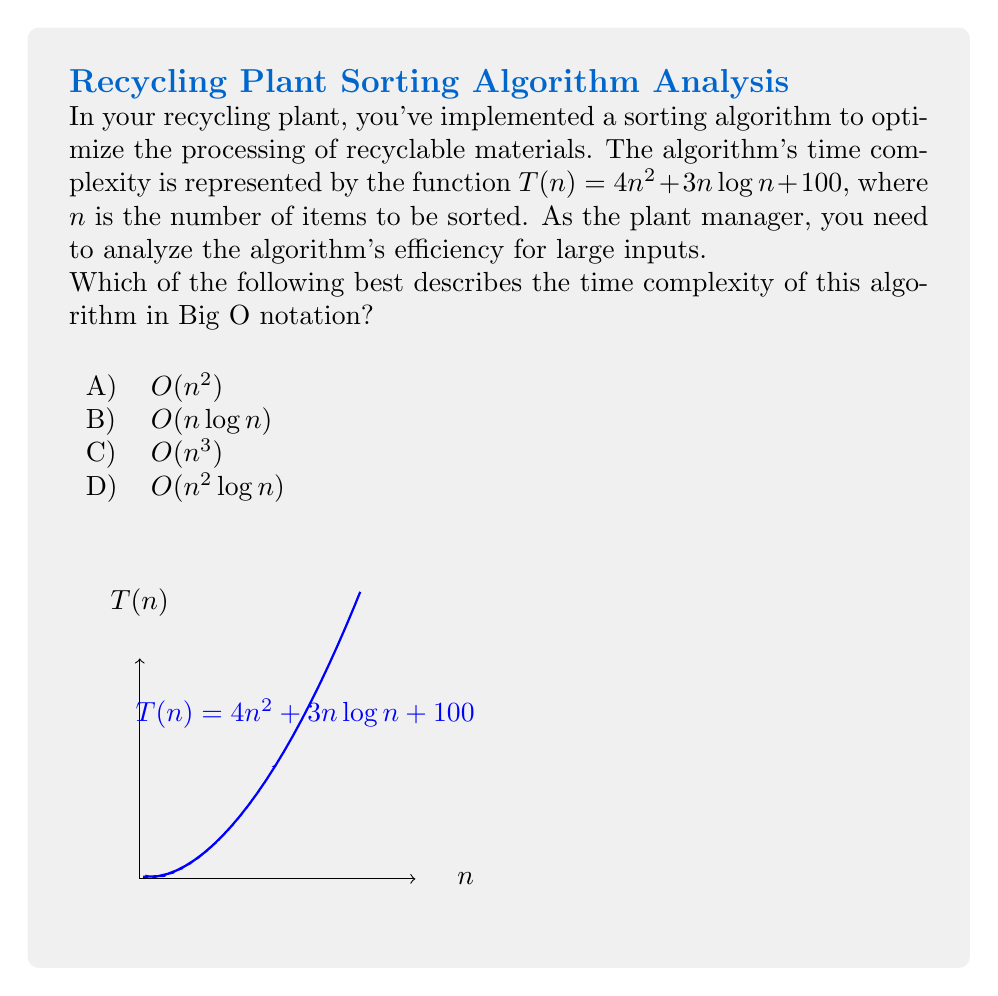Can you solve this math problem? To determine the time complexity in Big O notation, we need to identify the dominant term in the given function as $n$ approaches infinity. Let's analyze each term:

1) $4n^2$: This is a quadratic term.
2) $3n\log n$: This is a linearithmic term.
3) $100$: This is a constant term.

Step 1: Compare the growth rates
As $n$ increases, the quadratic term $4n^2$ will grow faster than the linearithmic term $3n\log n$, and both will outgrow the constant term 100.

Step 2: Eliminate lower-order terms
We can drop the lower-order terms $3n\log n$ and 100, as they become insignificant for large $n$.

Step 3: Remove coefficients
In Big O notation, we ignore constant coefficients. So $4n^2$ becomes simply $n^2$.

Step 4: Express in Big O notation
The simplified expression is $O(n^2)$.

Therefore, the time complexity of this algorithm is $O(n^2)$, which corresponds to option A.

This quadratic time complexity suggests that as the number of items to be sorted increases, the processing time will increase quadratically, which may become a bottleneck for very large input sizes in your recycling plant.
Answer: $O(n^2)$ 